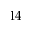<formula> <loc_0><loc_0><loc_500><loc_500>1 4</formula> 